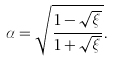<formula> <loc_0><loc_0><loc_500><loc_500>\alpha = \sqrt { \frac { 1 - \sqrt { \xi } } { 1 + \sqrt { \xi } } } .</formula> 